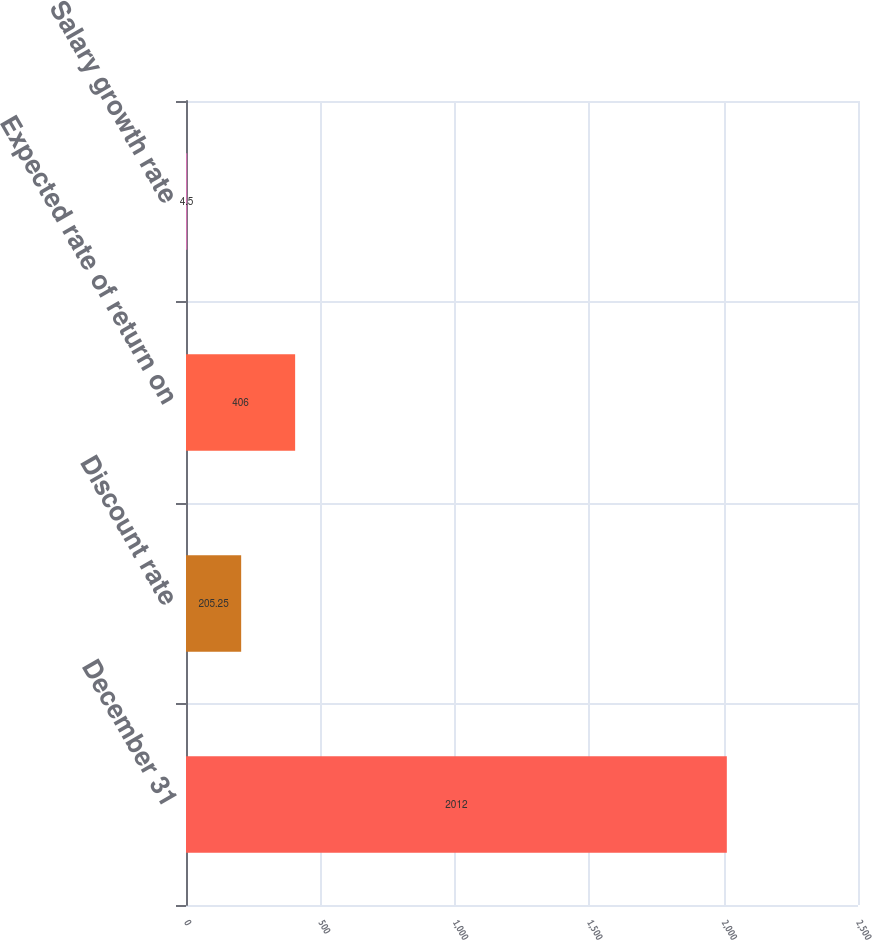Convert chart. <chart><loc_0><loc_0><loc_500><loc_500><bar_chart><fcel>December 31<fcel>Discount rate<fcel>Expected rate of return on<fcel>Salary growth rate<nl><fcel>2012<fcel>205.25<fcel>406<fcel>4.5<nl></chart> 